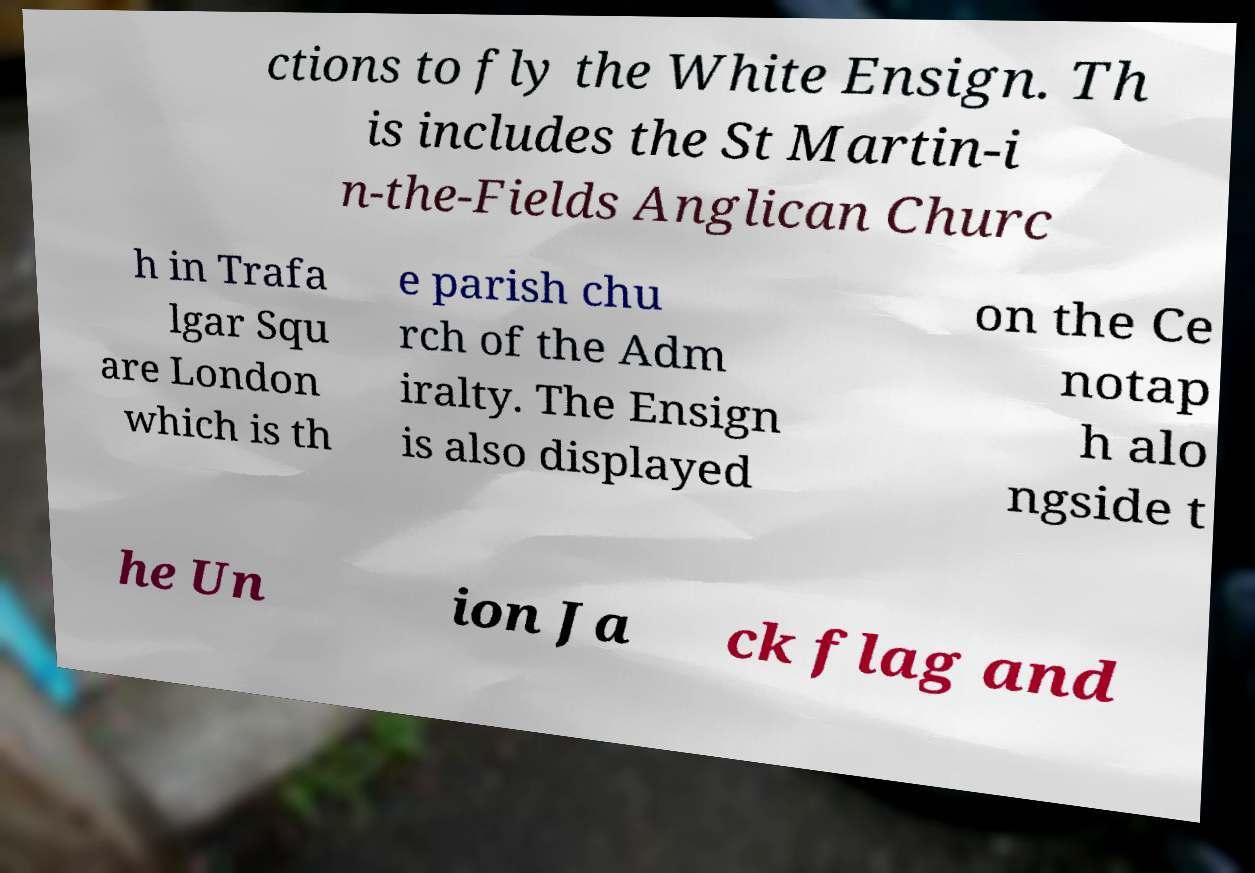There's text embedded in this image that I need extracted. Can you transcribe it verbatim? ctions to fly the White Ensign. Th is includes the St Martin-i n-the-Fields Anglican Churc h in Trafa lgar Squ are London which is th e parish chu rch of the Adm iralty. The Ensign is also displayed on the Ce notap h alo ngside t he Un ion Ja ck flag and 